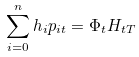<formula> <loc_0><loc_0><loc_500><loc_500>\sum _ { i = 0 } ^ { n } h _ { i } p _ { i t } = \Phi _ { t } H _ { t T }</formula> 